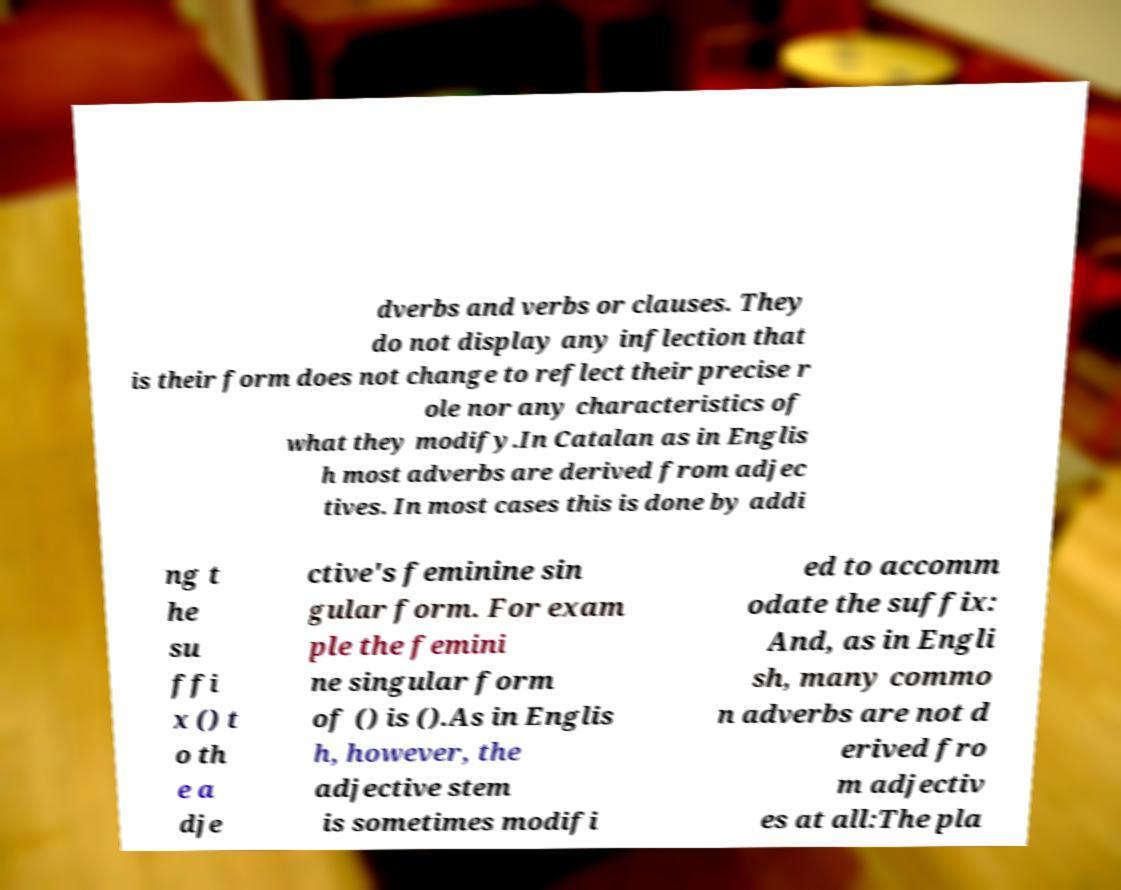I need the written content from this picture converted into text. Can you do that? dverbs and verbs or clauses. They do not display any inflection that is their form does not change to reflect their precise r ole nor any characteristics of what they modify.In Catalan as in Englis h most adverbs are derived from adjec tives. In most cases this is done by addi ng t he su ffi x () t o th e a dje ctive's feminine sin gular form. For exam ple the femini ne singular form of () is ().As in Englis h, however, the adjective stem is sometimes modifi ed to accomm odate the suffix: And, as in Engli sh, many commo n adverbs are not d erived fro m adjectiv es at all:The pla 